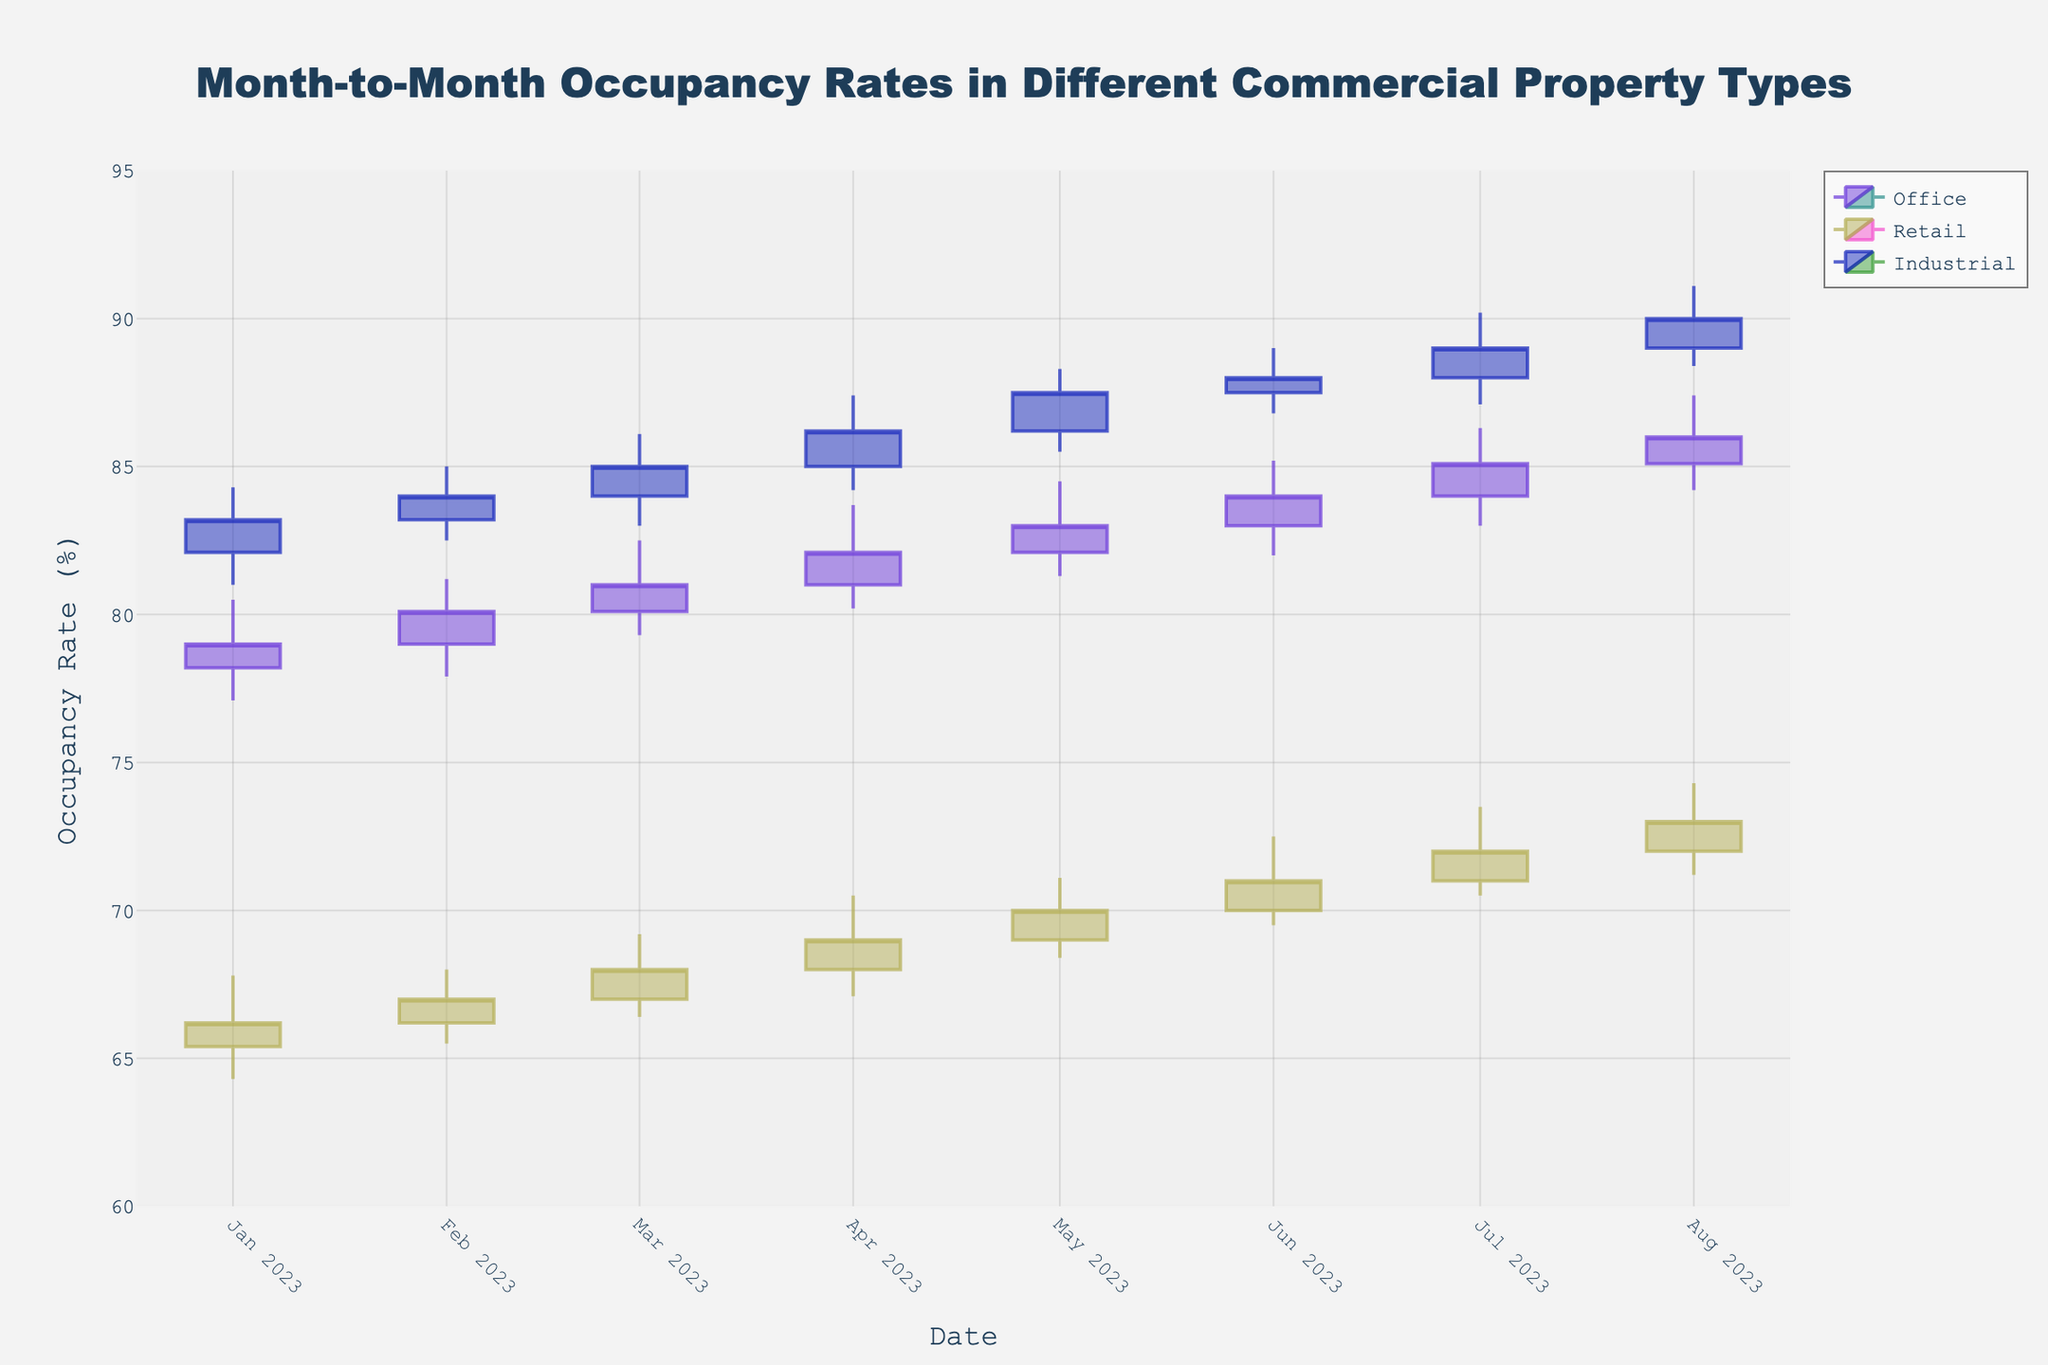What is the title of the figure? The title of the figure is displayed prominently at the top and is typically the largest text. It helps in understanding what the figure represents.
Answer: Month-to-Month Occupancy Rates in Different Commercial Property Types What are the three property types shown in the figure? Each candlestick trace in the plot represents a different property type. By looking at the legend, you can identify the property types included.
Answer: Office, Retail, Industrial Which property type showed the highest occupancy rate in August 2023? By examining the candlesticks for August 2023, we identify the highest 'Close' value among the three property types.
Answer: Industrial How does the occupancy rate for Retail properties in March 2023 compare to June 2023? Look at the 'Close' values for Retail properties in both March and June 2023 and compare them.
Answer: Higher in June 2023 What is the trend for Industrial properties from January to August 2023? By observing the 'Close' values of the candlesticks for Industrial properties over the given months, we can determine the trend.
Answer: Increasing trend On which date did Office properties have the lowest volume (difference between high and low)? Calculate the vertical difference between the 'High' and 'Low' values for Office properties and identify the date with the smallest difference.
Answer: January 1, 2023 Compare the peak occupancy rates (high values) between Office and Retail properties in July 2023. Which one had a higher peak? Look at the 'High' values for both Office and Retail properties in July 2023 and compare them to find the higher one.
Answer: Office What was the opening occupancy rate for Industrial properties in February 2023? Identify the 'Open' value for Industrial properties for the data point in February 2023.
Answer: 83.2 Calculate the average closing occupancy rate for Office properties over the entire period. Sum the 'Close' values for Office properties across all months and divide by the number of months to find the average.
Answer: (79.0 + 80.1 + 81.0 + 82.1 + 83.0 + 84.0 + 85.1 + 86.0) / 8 = 82.91 